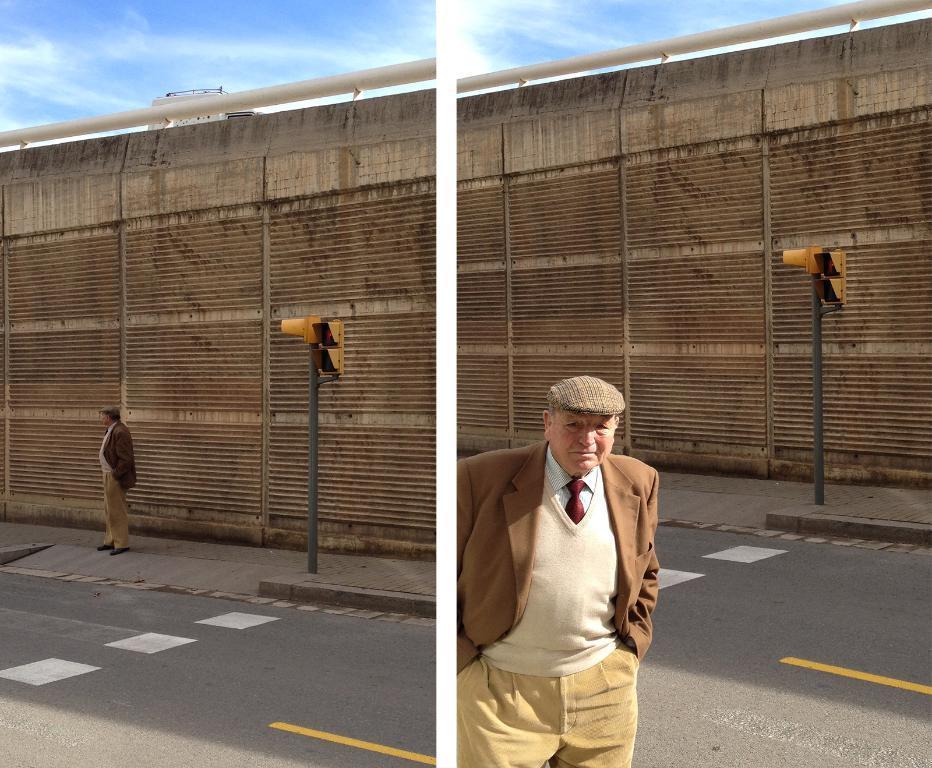Can you describe this image briefly? In this image there are two different images. On the right there is a man, he wears a suit, shirt, tie, trouser and hat and there is traffic signal, road, wall and sky. On the left there is a man, road, traffic signal, wall, sky and clouds. 